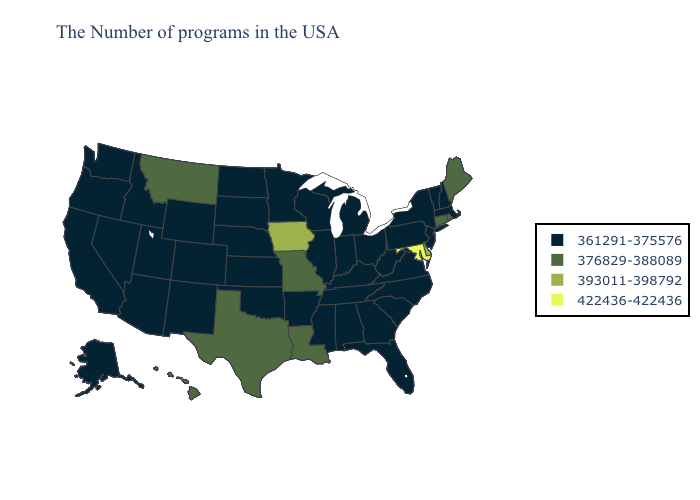What is the value of Massachusetts?
Quick response, please. 361291-375576. What is the value of New York?
Give a very brief answer. 361291-375576. Does Pennsylvania have the highest value in the Northeast?
Be succinct. No. What is the lowest value in the MidWest?
Keep it brief. 361291-375576. Among the states that border Idaho , which have the highest value?
Short answer required. Montana. What is the lowest value in the USA?
Short answer required. 361291-375576. What is the value of Nevada?
Write a very short answer. 361291-375576. Among the states that border New Mexico , which have the lowest value?
Be succinct. Oklahoma, Colorado, Utah, Arizona. Name the states that have a value in the range 361291-375576?
Concise answer only. Massachusetts, New Hampshire, Vermont, New York, New Jersey, Pennsylvania, Virginia, North Carolina, South Carolina, West Virginia, Ohio, Florida, Georgia, Michigan, Kentucky, Indiana, Alabama, Tennessee, Wisconsin, Illinois, Mississippi, Arkansas, Minnesota, Kansas, Nebraska, Oklahoma, South Dakota, North Dakota, Wyoming, Colorado, New Mexico, Utah, Arizona, Idaho, Nevada, California, Washington, Oregon, Alaska. What is the lowest value in states that border North Dakota?
Write a very short answer. 361291-375576. What is the lowest value in the USA?
Short answer required. 361291-375576. What is the value of Ohio?
Quick response, please. 361291-375576. What is the value of Maryland?
Keep it brief. 422436-422436. Name the states that have a value in the range 422436-422436?
Give a very brief answer. Maryland. What is the value of South Dakota?
Write a very short answer. 361291-375576. 